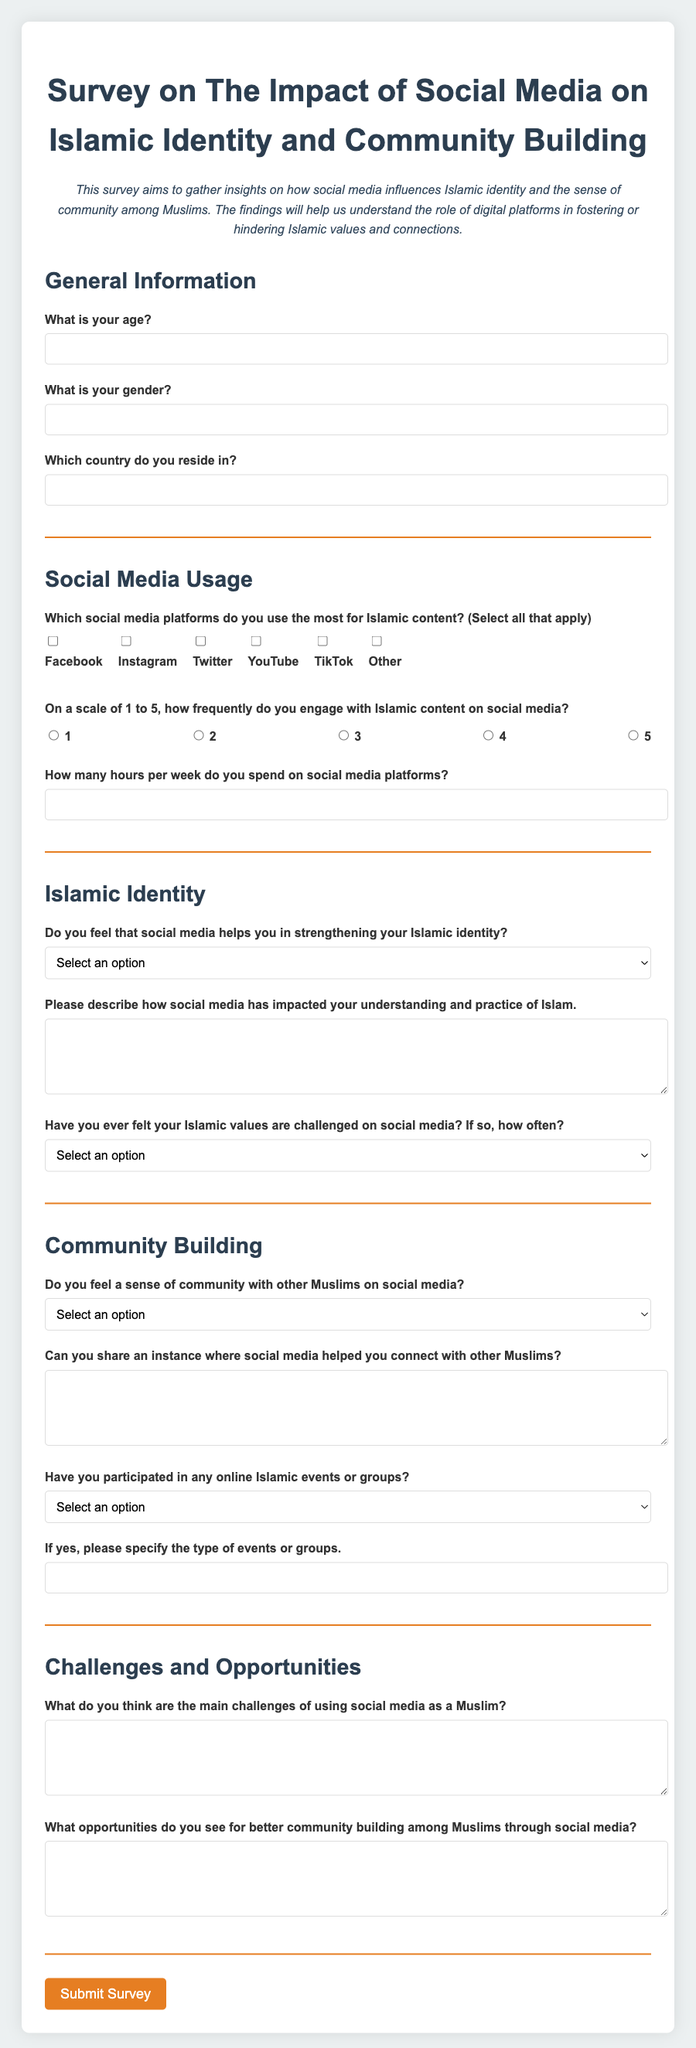What is the name of the survey? The title of the survey reflects the main topic it addresses, which is about social media's influence on Islamic identity and community building.
Answer: Survey on The Impact of Social Media on Islamic Identity and Community Building What is the maximum number of participants the form is designed for? The document doesn't specify a maximum number of participants; it is an open survey.
Answer: Not specified What options are given for the main social media platforms used for Islamic content? The survey provides a list of platforms where participants can indicate their usage for Islamic content.
Answer: Facebook, Instagram, Twitter, YouTube, TikTok, Other What is one of the challenges mentioned in the survey regarding social media use as a Muslim? The survey prompts respondents to share challenges they face with social media usage, highlighting a concern for Islamic users.
Answer: Challenges of using social media as a Muslim What type of events does the survey ask if participants have participated in? It specifically addresses the types of online events or groups that participants may have attended, ensuring relevance to their experience.
Answer: Online Islamic events or groups 